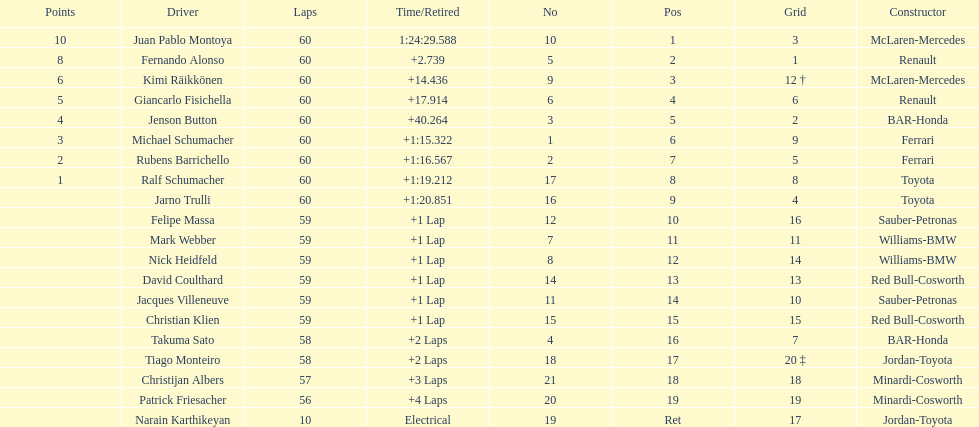What is the number of toyota's on the list? 4. 